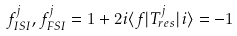Convert formula to latex. <formula><loc_0><loc_0><loc_500><loc_500>f ^ { j } _ { I S I } , f ^ { j } _ { F S I } = 1 + 2 i \langle f | T ^ { j } _ { r e s } | i \rangle = - 1</formula> 